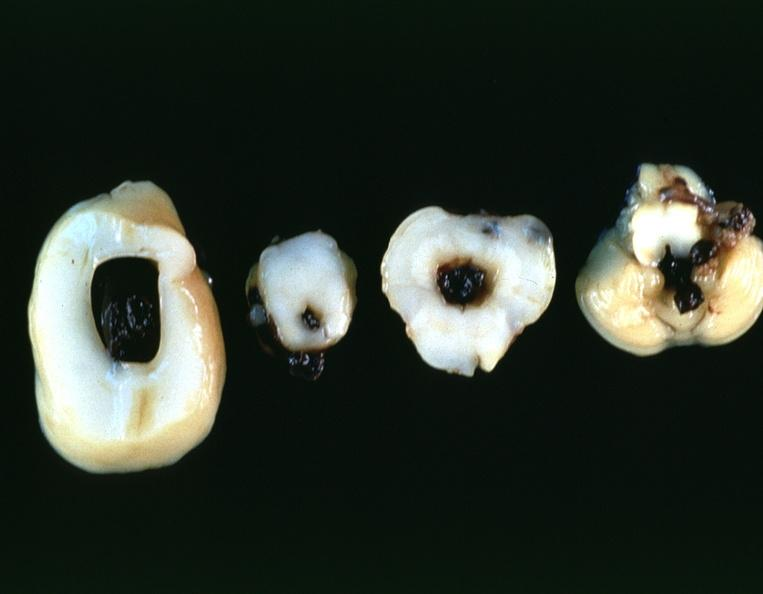does this image show brain, intraventricular hemmorrhage in a prematue baby with hyaline membrane disease?
Answer the question using a single word or phrase. Yes 